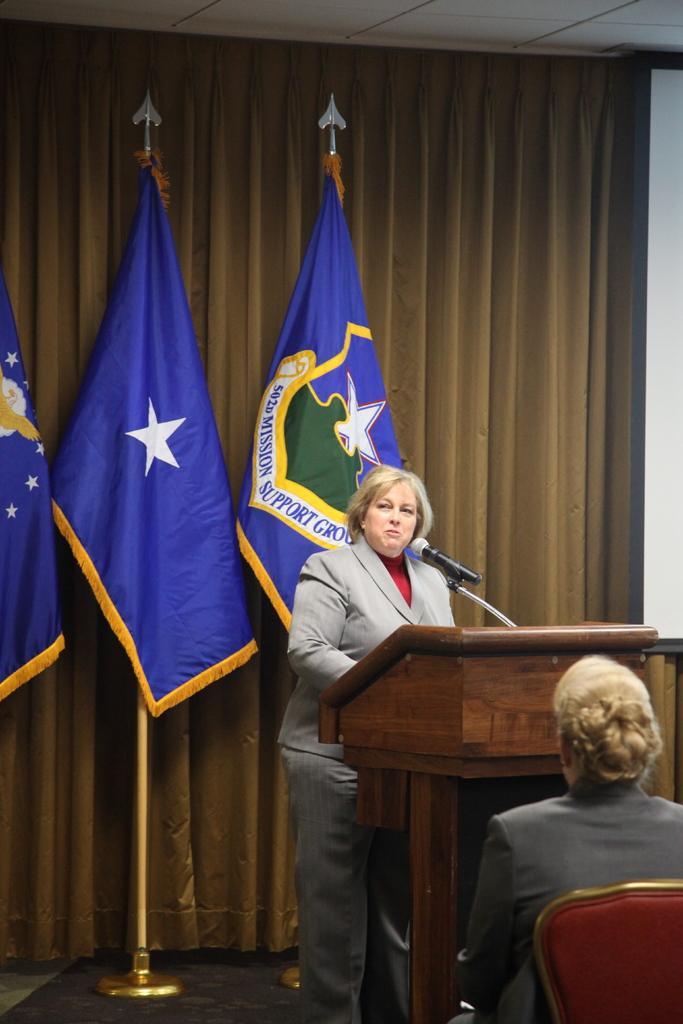Please provide a concise description of this image. On the right a woman is sitting on a chair and a woman is standing on the floor at the podium and on the podium we can see a microphone. In the background there are flags to poles,curtain,board and ceiling. 